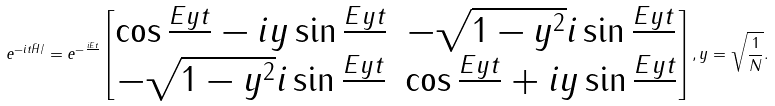Convert formula to latex. <formula><loc_0><loc_0><loc_500><loc_500>e ^ { - i t \bar { H } / } = e ^ { - \frac { i E t } { } } \left [ \begin{matrix} \cos { \frac { E y t } { } } - i y \sin { \frac { E y t } { } } & - \sqrt { 1 - y ^ { 2 } } i \sin { \frac { E y t } { } } \\ - \sqrt { 1 - y ^ { 2 } } i \sin { \frac { E y t } { } } & \cos { \frac { E y t } { } } + i y \sin { \frac { E y t } { } } \end{matrix} \right ] , y = \sqrt { \frac { 1 } { N } } .</formula> 